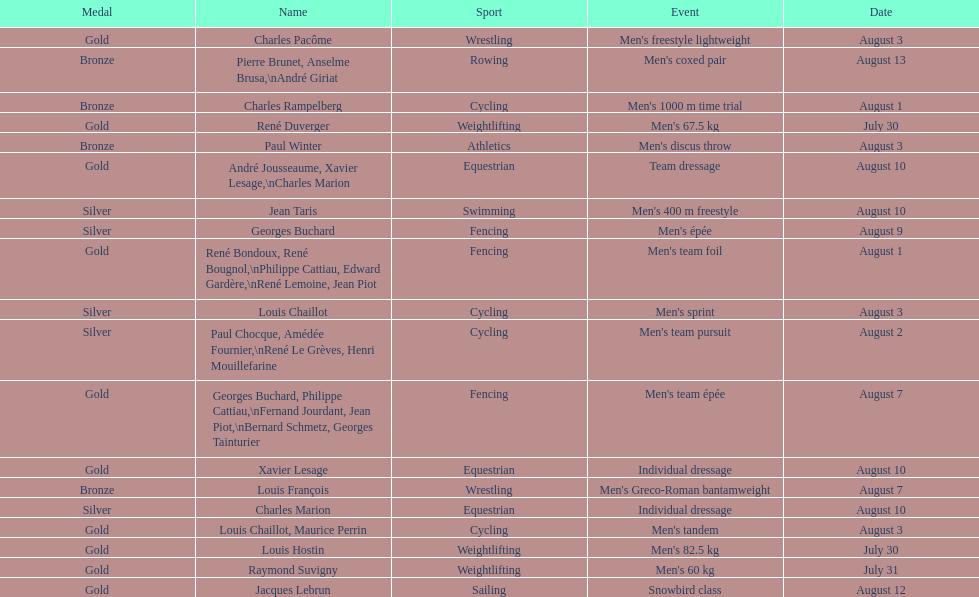Help me parse the entirety of this table. {'header': ['Medal', 'Name', 'Sport', 'Event', 'Date'], 'rows': [['Gold', 'Charles Pacôme', 'Wrestling', "Men's freestyle lightweight", 'August 3'], ['Bronze', 'Pierre Brunet, Anselme Brusa,\\nAndré Giriat', 'Rowing', "Men's coxed pair", 'August 13'], ['Bronze', 'Charles Rampelberg', 'Cycling', "Men's 1000 m time trial", 'August 1'], ['Gold', 'René Duverger', 'Weightlifting', "Men's 67.5 kg", 'July 30'], ['Bronze', 'Paul Winter', 'Athletics', "Men's discus throw", 'August 3'], ['Gold', 'André Jousseaume, Xavier Lesage,\\nCharles Marion', 'Equestrian', 'Team dressage', 'August 10'], ['Silver', 'Jean Taris', 'Swimming', "Men's 400 m freestyle", 'August 10'], ['Silver', 'Georges Buchard', 'Fencing', "Men's épée", 'August 9'], ['Gold', 'René Bondoux, René Bougnol,\\nPhilippe Cattiau, Edward Gardère,\\nRené Lemoine, Jean Piot', 'Fencing', "Men's team foil", 'August 1'], ['Silver', 'Louis Chaillot', 'Cycling', "Men's sprint", 'August 3'], ['Silver', 'Paul Chocque, Amédée Fournier,\\nRené Le Grèves, Henri Mouillefarine', 'Cycling', "Men's team pursuit", 'August 2'], ['Gold', 'Georges Buchard, Philippe Cattiau,\\nFernand Jourdant, Jean Piot,\\nBernard Schmetz, Georges Tainturier', 'Fencing', "Men's team épée", 'August 7'], ['Gold', 'Xavier Lesage', 'Equestrian', 'Individual dressage', 'August 10'], ['Bronze', 'Louis François', 'Wrestling', "Men's Greco-Roman bantamweight", 'August 7'], ['Silver', 'Charles Marion', 'Equestrian', 'Individual dressage', 'August 10'], ['Gold', 'Louis Chaillot, Maurice Perrin', 'Cycling', "Men's tandem", 'August 3'], ['Gold', 'Louis Hostin', 'Weightlifting', "Men's 82.5 kg", 'July 30'], ['Gold', 'Raymond Suvigny', 'Weightlifting', "Men's 60 kg", 'July 31'], ['Gold', 'Jacques Lebrun', 'Sailing', 'Snowbird class', 'August 12']]} Louis chaillot won a gold medal for cycling and a silver medal for what sport? Cycling. 